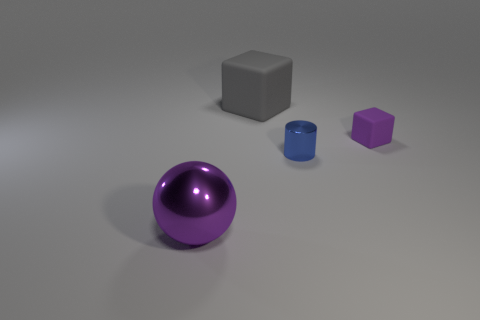What number of other metallic spheres have the same color as the big ball?
Offer a terse response. 0. Are there fewer purple objects in front of the large sphere than purple rubber blocks in front of the small shiny thing?
Offer a terse response. No. How many tiny things are to the right of the small blue metallic object?
Keep it short and to the point. 1. Is there another large yellow ball that has the same material as the ball?
Your answer should be very brief. No. Is the number of big blocks that are to the right of the blue metal object greater than the number of things that are behind the large purple sphere?
Keep it short and to the point. No. What size is the cylinder?
Your response must be concise. Small. What is the shape of the big thing left of the large gray rubber thing?
Give a very brief answer. Sphere. Does the big purple shiny thing have the same shape as the tiny blue metallic thing?
Make the answer very short. No. Is the number of large gray rubber cubes on the left side of the big rubber thing the same as the number of tiny cylinders?
Keep it short and to the point. No. The tiny blue thing has what shape?
Keep it short and to the point. Cylinder. 